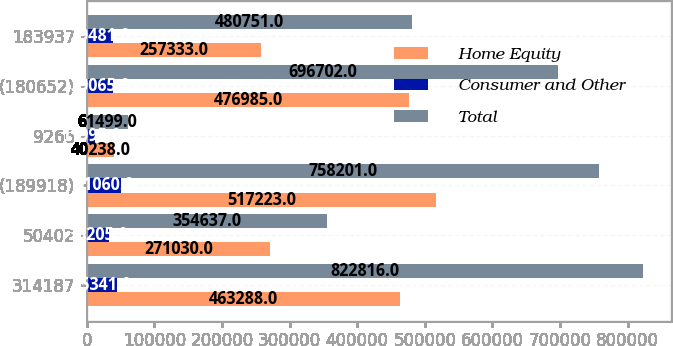<chart> <loc_0><loc_0><loc_500><loc_500><stacked_bar_chart><ecel><fcel>314187<fcel>50402<fcel>(189918)<fcel>9266<fcel>(180652)<fcel>183937<nl><fcel>Home Equity<fcel>463288<fcel>271030<fcel>517223<fcel>40238<fcel>476985<fcel>257333<nl><fcel>Consumer and Other<fcel>45341<fcel>33205<fcel>51060<fcel>11995<fcel>39065<fcel>39481<nl><fcel>Total<fcel>822816<fcel>354637<fcel>758201<fcel>61499<fcel>696702<fcel>480751<nl></chart> 